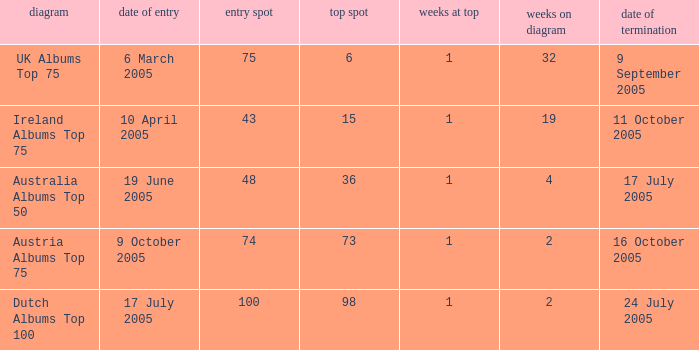What is the date of entry for the UK Albums Top 75 chart? 6 March 2005. 